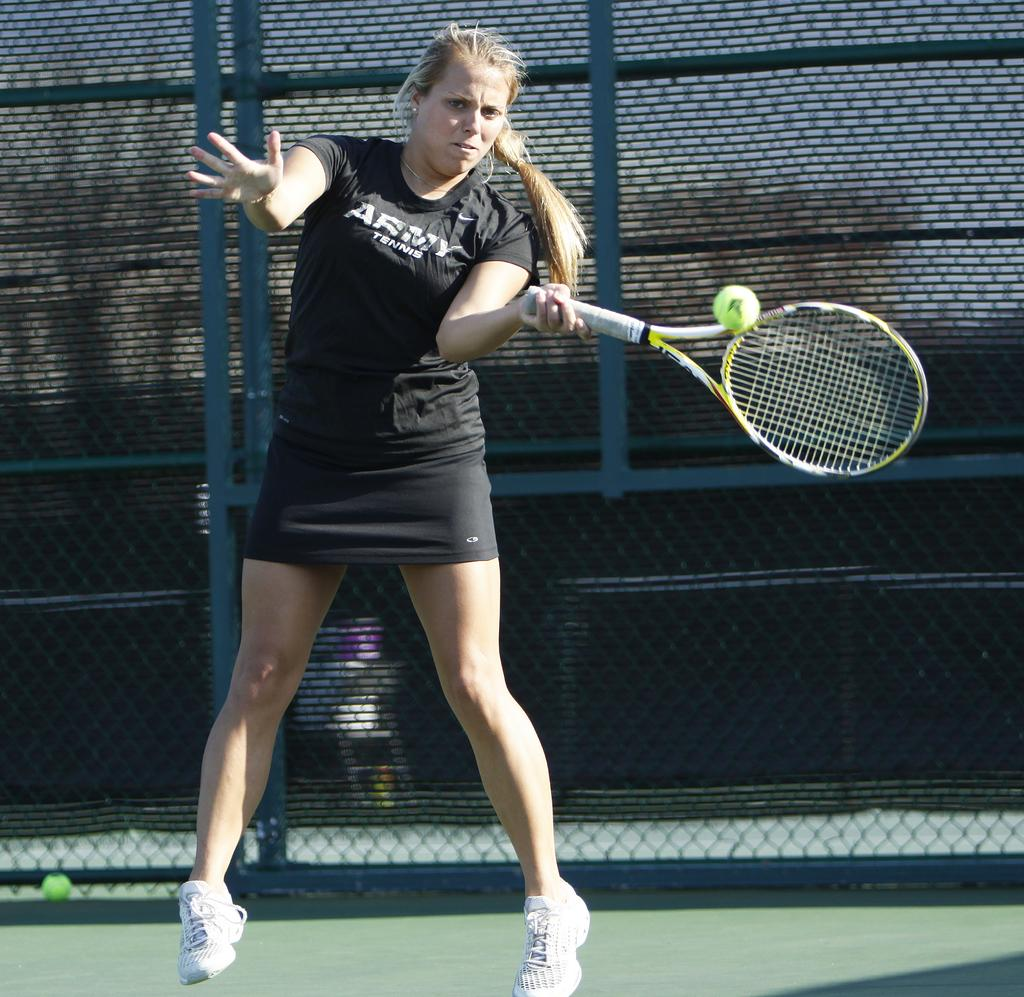Who is the main subject in the image? There is a woman in the image. What is the woman doing in the image? The woman is playing with a ball and holding a racket in her hands. What is the woman standing on in the image? The woman is standing on the ground. What can be seen in the background of the image? There is fencing visible in the background of the image. What type of nail is the woman using to hit the ball in the image? There is no nail present in the image; the woman is using a racket to play with the ball. What street is the woman playing on in the image? The image does not show a street; it only shows the woman playing with a ball and fencing in the background. 